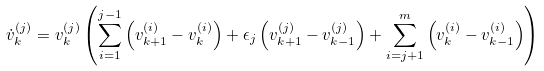<formula> <loc_0><loc_0><loc_500><loc_500>\dot { v } _ { k } ^ { ( j ) } = v _ { k } ^ { ( j ) } \left ( \sum _ { i = 1 } ^ { j - 1 } \left ( v _ { k + 1 } ^ { ( i ) } - v _ { k } ^ { ( i ) } \right ) + \epsilon _ { j } \left ( v _ { k + 1 } ^ { ( j ) } - v _ { k - 1 } ^ { ( j ) } \right ) + \sum _ { i = j + 1 } ^ { m } \left ( v _ { k } ^ { ( i ) } - v _ { k - 1 } ^ { ( i ) } \right ) \right )</formula> 